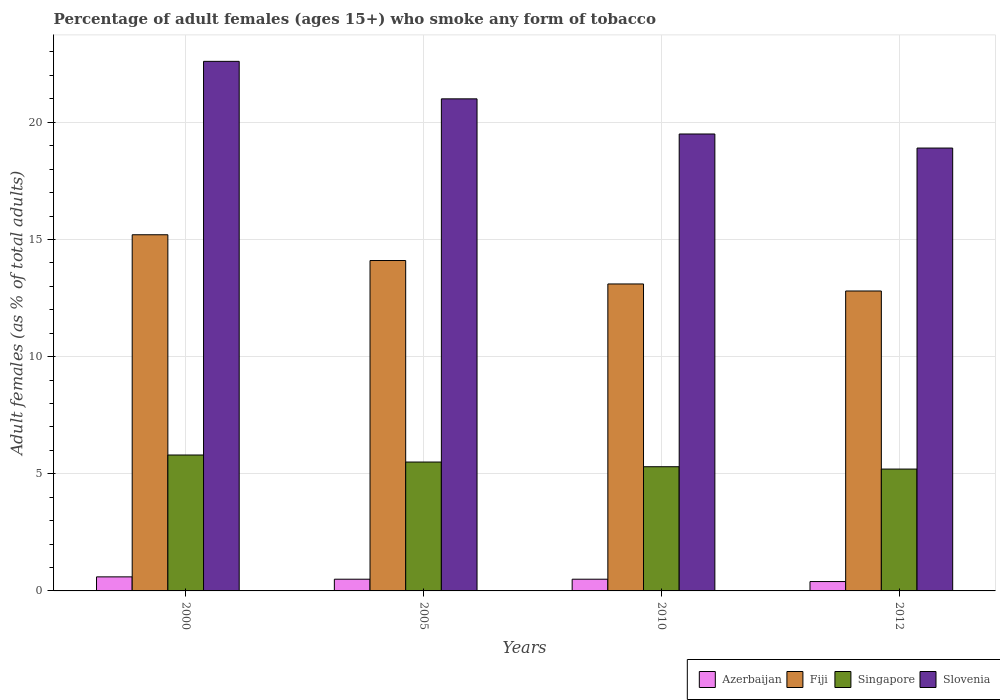Are the number of bars per tick equal to the number of legend labels?
Make the answer very short. Yes. Are the number of bars on each tick of the X-axis equal?
Ensure brevity in your answer.  Yes. How many bars are there on the 2nd tick from the left?
Offer a terse response. 4. What is the percentage of adult females who smoke in Azerbaijan in 2000?
Provide a short and direct response. 0.6. Across all years, what is the maximum percentage of adult females who smoke in Slovenia?
Keep it short and to the point. 22.6. Across all years, what is the minimum percentage of adult females who smoke in Slovenia?
Provide a short and direct response. 18.9. In which year was the percentage of adult females who smoke in Fiji minimum?
Provide a short and direct response. 2012. What is the total percentage of adult females who smoke in Azerbaijan in the graph?
Offer a terse response. 2. What is the difference between the percentage of adult females who smoke in Singapore in 2005 and that in 2010?
Make the answer very short. 0.2. What is the difference between the percentage of adult females who smoke in Singapore in 2000 and the percentage of adult females who smoke in Azerbaijan in 2005?
Give a very brief answer. 5.3. What is the ratio of the percentage of adult females who smoke in Singapore in 2000 to that in 2012?
Your answer should be compact. 1.12. Is the difference between the percentage of adult females who smoke in Slovenia in 2005 and 2010 greater than the difference between the percentage of adult females who smoke in Azerbaijan in 2005 and 2010?
Offer a terse response. Yes. What is the difference between the highest and the second highest percentage of adult females who smoke in Singapore?
Ensure brevity in your answer.  0.3. What is the difference between the highest and the lowest percentage of adult females who smoke in Fiji?
Keep it short and to the point. 2.4. Is the sum of the percentage of adult females who smoke in Slovenia in 2010 and 2012 greater than the maximum percentage of adult females who smoke in Azerbaijan across all years?
Provide a succinct answer. Yes. Is it the case that in every year, the sum of the percentage of adult females who smoke in Fiji and percentage of adult females who smoke in Singapore is greater than the sum of percentage of adult females who smoke in Slovenia and percentage of adult females who smoke in Azerbaijan?
Offer a very short reply. Yes. What does the 3rd bar from the left in 2010 represents?
Your response must be concise. Singapore. What does the 1st bar from the right in 2000 represents?
Offer a terse response. Slovenia. Are all the bars in the graph horizontal?
Make the answer very short. No. Are the values on the major ticks of Y-axis written in scientific E-notation?
Ensure brevity in your answer.  No. Where does the legend appear in the graph?
Your answer should be compact. Bottom right. What is the title of the graph?
Provide a succinct answer. Percentage of adult females (ages 15+) who smoke any form of tobacco. What is the label or title of the X-axis?
Your answer should be compact. Years. What is the label or title of the Y-axis?
Offer a very short reply. Adult females (as % of total adults). What is the Adult females (as % of total adults) in Azerbaijan in 2000?
Your answer should be compact. 0.6. What is the Adult females (as % of total adults) of Fiji in 2000?
Provide a succinct answer. 15.2. What is the Adult females (as % of total adults) in Slovenia in 2000?
Keep it short and to the point. 22.6. What is the Adult females (as % of total adults) in Azerbaijan in 2005?
Make the answer very short. 0.5. What is the Adult females (as % of total adults) of Azerbaijan in 2010?
Your response must be concise. 0.5. What is the Adult females (as % of total adults) of Fiji in 2010?
Your answer should be very brief. 13.1. What is the Adult females (as % of total adults) in Slovenia in 2010?
Your answer should be compact. 19.5. What is the Adult females (as % of total adults) of Fiji in 2012?
Ensure brevity in your answer.  12.8. What is the Adult females (as % of total adults) of Singapore in 2012?
Give a very brief answer. 5.2. Across all years, what is the maximum Adult females (as % of total adults) in Slovenia?
Offer a very short reply. 22.6. Across all years, what is the minimum Adult females (as % of total adults) of Azerbaijan?
Your answer should be very brief. 0.4. Across all years, what is the minimum Adult females (as % of total adults) of Slovenia?
Your answer should be very brief. 18.9. What is the total Adult females (as % of total adults) of Azerbaijan in the graph?
Offer a very short reply. 2. What is the total Adult females (as % of total adults) of Fiji in the graph?
Your response must be concise. 55.2. What is the total Adult females (as % of total adults) in Singapore in the graph?
Your answer should be very brief. 21.8. What is the difference between the Adult females (as % of total adults) of Fiji in 2000 and that in 2010?
Offer a terse response. 2.1. What is the difference between the Adult females (as % of total adults) of Slovenia in 2000 and that in 2010?
Your answer should be compact. 3.1. What is the difference between the Adult females (as % of total adults) in Azerbaijan in 2000 and that in 2012?
Provide a succinct answer. 0.2. What is the difference between the Adult females (as % of total adults) of Fiji in 2000 and that in 2012?
Your answer should be very brief. 2.4. What is the difference between the Adult females (as % of total adults) of Singapore in 2000 and that in 2012?
Your response must be concise. 0.6. What is the difference between the Adult females (as % of total adults) of Slovenia in 2000 and that in 2012?
Your answer should be very brief. 3.7. What is the difference between the Adult females (as % of total adults) of Azerbaijan in 2005 and that in 2010?
Provide a succinct answer. 0. What is the difference between the Adult females (as % of total adults) of Singapore in 2005 and that in 2010?
Your answer should be very brief. 0.2. What is the difference between the Adult females (as % of total adults) of Slovenia in 2005 and that in 2010?
Your answer should be compact. 1.5. What is the difference between the Adult females (as % of total adults) in Azerbaijan in 2005 and that in 2012?
Provide a short and direct response. 0.1. What is the difference between the Adult females (as % of total adults) of Slovenia in 2005 and that in 2012?
Your response must be concise. 2.1. What is the difference between the Adult females (as % of total adults) in Azerbaijan in 2010 and that in 2012?
Offer a terse response. 0.1. What is the difference between the Adult females (as % of total adults) in Fiji in 2010 and that in 2012?
Give a very brief answer. 0.3. What is the difference between the Adult females (as % of total adults) in Slovenia in 2010 and that in 2012?
Your answer should be compact. 0.6. What is the difference between the Adult females (as % of total adults) of Azerbaijan in 2000 and the Adult females (as % of total adults) of Singapore in 2005?
Your answer should be compact. -4.9. What is the difference between the Adult females (as % of total adults) of Azerbaijan in 2000 and the Adult females (as % of total adults) of Slovenia in 2005?
Your answer should be compact. -20.4. What is the difference between the Adult females (as % of total adults) of Fiji in 2000 and the Adult females (as % of total adults) of Slovenia in 2005?
Your answer should be very brief. -5.8. What is the difference between the Adult females (as % of total adults) of Singapore in 2000 and the Adult females (as % of total adults) of Slovenia in 2005?
Ensure brevity in your answer.  -15.2. What is the difference between the Adult females (as % of total adults) in Azerbaijan in 2000 and the Adult females (as % of total adults) in Fiji in 2010?
Your answer should be compact. -12.5. What is the difference between the Adult females (as % of total adults) in Azerbaijan in 2000 and the Adult females (as % of total adults) in Slovenia in 2010?
Offer a terse response. -18.9. What is the difference between the Adult females (as % of total adults) in Fiji in 2000 and the Adult females (as % of total adults) in Slovenia in 2010?
Your answer should be very brief. -4.3. What is the difference between the Adult females (as % of total adults) in Singapore in 2000 and the Adult females (as % of total adults) in Slovenia in 2010?
Ensure brevity in your answer.  -13.7. What is the difference between the Adult females (as % of total adults) of Azerbaijan in 2000 and the Adult females (as % of total adults) of Singapore in 2012?
Your answer should be very brief. -4.6. What is the difference between the Adult females (as % of total adults) of Azerbaijan in 2000 and the Adult females (as % of total adults) of Slovenia in 2012?
Make the answer very short. -18.3. What is the difference between the Adult females (as % of total adults) of Singapore in 2000 and the Adult females (as % of total adults) of Slovenia in 2012?
Make the answer very short. -13.1. What is the difference between the Adult females (as % of total adults) in Azerbaijan in 2005 and the Adult females (as % of total adults) in Fiji in 2010?
Provide a succinct answer. -12.6. What is the difference between the Adult females (as % of total adults) in Azerbaijan in 2005 and the Adult females (as % of total adults) in Singapore in 2010?
Offer a terse response. -4.8. What is the difference between the Adult females (as % of total adults) in Azerbaijan in 2005 and the Adult females (as % of total adults) in Slovenia in 2010?
Your answer should be compact. -19. What is the difference between the Adult females (as % of total adults) of Fiji in 2005 and the Adult females (as % of total adults) of Singapore in 2010?
Your answer should be very brief. 8.8. What is the difference between the Adult females (as % of total adults) of Fiji in 2005 and the Adult females (as % of total adults) of Slovenia in 2010?
Provide a short and direct response. -5.4. What is the difference between the Adult females (as % of total adults) of Singapore in 2005 and the Adult females (as % of total adults) of Slovenia in 2010?
Offer a very short reply. -14. What is the difference between the Adult females (as % of total adults) in Azerbaijan in 2005 and the Adult females (as % of total adults) in Fiji in 2012?
Offer a terse response. -12.3. What is the difference between the Adult females (as % of total adults) in Azerbaijan in 2005 and the Adult females (as % of total adults) in Slovenia in 2012?
Ensure brevity in your answer.  -18.4. What is the difference between the Adult females (as % of total adults) in Fiji in 2005 and the Adult females (as % of total adults) in Singapore in 2012?
Your answer should be very brief. 8.9. What is the difference between the Adult females (as % of total adults) of Azerbaijan in 2010 and the Adult females (as % of total adults) of Fiji in 2012?
Your response must be concise. -12.3. What is the difference between the Adult females (as % of total adults) of Azerbaijan in 2010 and the Adult females (as % of total adults) of Slovenia in 2012?
Your answer should be compact. -18.4. What is the average Adult females (as % of total adults) of Azerbaijan per year?
Keep it short and to the point. 0.5. What is the average Adult females (as % of total adults) of Fiji per year?
Give a very brief answer. 13.8. What is the average Adult females (as % of total adults) of Singapore per year?
Provide a short and direct response. 5.45. In the year 2000, what is the difference between the Adult females (as % of total adults) in Azerbaijan and Adult females (as % of total adults) in Fiji?
Provide a short and direct response. -14.6. In the year 2000, what is the difference between the Adult females (as % of total adults) in Azerbaijan and Adult females (as % of total adults) in Singapore?
Your answer should be compact. -5.2. In the year 2000, what is the difference between the Adult females (as % of total adults) in Azerbaijan and Adult females (as % of total adults) in Slovenia?
Offer a very short reply. -22. In the year 2000, what is the difference between the Adult females (as % of total adults) of Fiji and Adult females (as % of total adults) of Slovenia?
Provide a short and direct response. -7.4. In the year 2000, what is the difference between the Adult females (as % of total adults) of Singapore and Adult females (as % of total adults) of Slovenia?
Provide a short and direct response. -16.8. In the year 2005, what is the difference between the Adult females (as % of total adults) in Azerbaijan and Adult females (as % of total adults) in Slovenia?
Keep it short and to the point. -20.5. In the year 2005, what is the difference between the Adult females (as % of total adults) in Fiji and Adult females (as % of total adults) in Singapore?
Offer a terse response. 8.6. In the year 2005, what is the difference between the Adult females (as % of total adults) of Singapore and Adult females (as % of total adults) of Slovenia?
Make the answer very short. -15.5. In the year 2010, what is the difference between the Adult females (as % of total adults) in Azerbaijan and Adult females (as % of total adults) in Fiji?
Provide a succinct answer. -12.6. In the year 2010, what is the difference between the Adult females (as % of total adults) in Azerbaijan and Adult females (as % of total adults) in Singapore?
Ensure brevity in your answer.  -4.8. In the year 2010, what is the difference between the Adult females (as % of total adults) in Fiji and Adult females (as % of total adults) in Singapore?
Offer a very short reply. 7.8. In the year 2012, what is the difference between the Adult females (as % of total adults) of Azerbaijan and Adult females (as % of total adults) of Slovenia?
Provide a succinct answer. -18.5. In the year 2012, what is the difference between the Adult females (as % of total adults) of Fiji and Adult females (as % of total adults) of Singapore?
Your answer should be compact. 7.6. In the year 2012, what is the difference between the Adult females (as % of total adults) in Fiji and Adult females (as % of total adults) in Slovenia?
Give a very brief answer. -6.1. In the year 2012, what is the difference between the Adult females (as % of total adults) in Singapore and Adult females (as % of total adults) in Slovenia?
Your answer should be compact. -13.7. What is the ratio of the Adult females (as % of total adults) in Azerbaijan in 2000 to that in 2005?
Offer a terse response. 1.2. What is the ratio of the Adult females (as % of total adults) in Fiji in 2000 to that in 2005?
Your answer should be compact. 1.08. What is the ratio of the Adult females (as % of total adults) of Singapore in 2000 to that in 2005?
Ensure brevity in your answer.  1.05. What is the ratio of the Adult females (as % of total adults) in Slovenia in 2000 to that in 2005?
Provide a succinct answer. 1.08. What is the ratio of the Adult females (as % of total adults) in Fiji in 2000 to that in 2010?
Provide a short and direct response. 1.16. What is the ratio of the Adult females (as % of total adults) of Singapore in 2000 to that in 2010?
Your response must be concise. 1.09. What is the ratio of the Adult females (as % of total adults) in Slovenia in 2000 to that in 2010?
Offer a terse response. 1.16. What is the ratio of the Adult females (as % of total adults) of Fiji in 2000 to that in 2012?
Ensure brevity in your answer.  1.19. What is the ratio of the Adult females (as % of total adults) in Singapore in 2000 to that in 2012?
Provide a short and direct response. 1.12. What is the ratio of the Adult females (as % of total adults) in Slovenia in 2000 to that in 2012?
Your response must be concise. 1.2. What is the ratio of the Adult females (as % of total adults) in Azerbaijan in 2005 to that in 2010?
Keep it short and to the point. 1. What is the ratio of the Adult females (as % of total adults) of Fiji in 2005 to that in 2010?
Provide a succinct answer. 1.08. What is the ratio of the Adult females (as % of total adults) of Singapore in 2005 to that in 2010?
Provide a short and direct response. 1.04. What is the ratio of the Adult females (as % of total adults) of Slovenia in 2005 to that in 2010?
Offer a very short reply. 1.08. What is the ratio of the Adult females (as % of total adults) of Azerbaijan in 2005 to that in 2012?
Make the answer very short. 1.25. What is the ratio of the Adult females (as % of total adults) in Fiji in 2005 to that in 2012?
Your answer should be very brief. 1.1. What is the ratio of the Adult females (as % of total adults) of Singapore in 2005 to that in 2012?
Keep it short and to the point. 1.06. What is the ratio of the Adult females (as % of total adults) of Fiji in 2010 to that in 2012?
Provide a succinct answer. 1.02. What is the ratio of the Adult females (as % of total adults) of Singapore in 2010 to that in 2012?
Keep it short and to the point. 1.02. What is the ratio of the Adult females (as % of total adults) in Slovenia in 2010 to that in 2012?
Offer a very short reply. 1.03. What is the difference between the highest and the second highest Adult females (as % of total adults) in Azerbaijan?
Ensure brevity in your answer.  0.1. What is the difference between the highest and the second highest Adult females (as % of total adults) of Fiji?
Your response must be concise. 1.1. What is the difference between the highest and the lowest Adult females (as % of total adults) of Slovenia?
Offer a terse response. 3.7. 